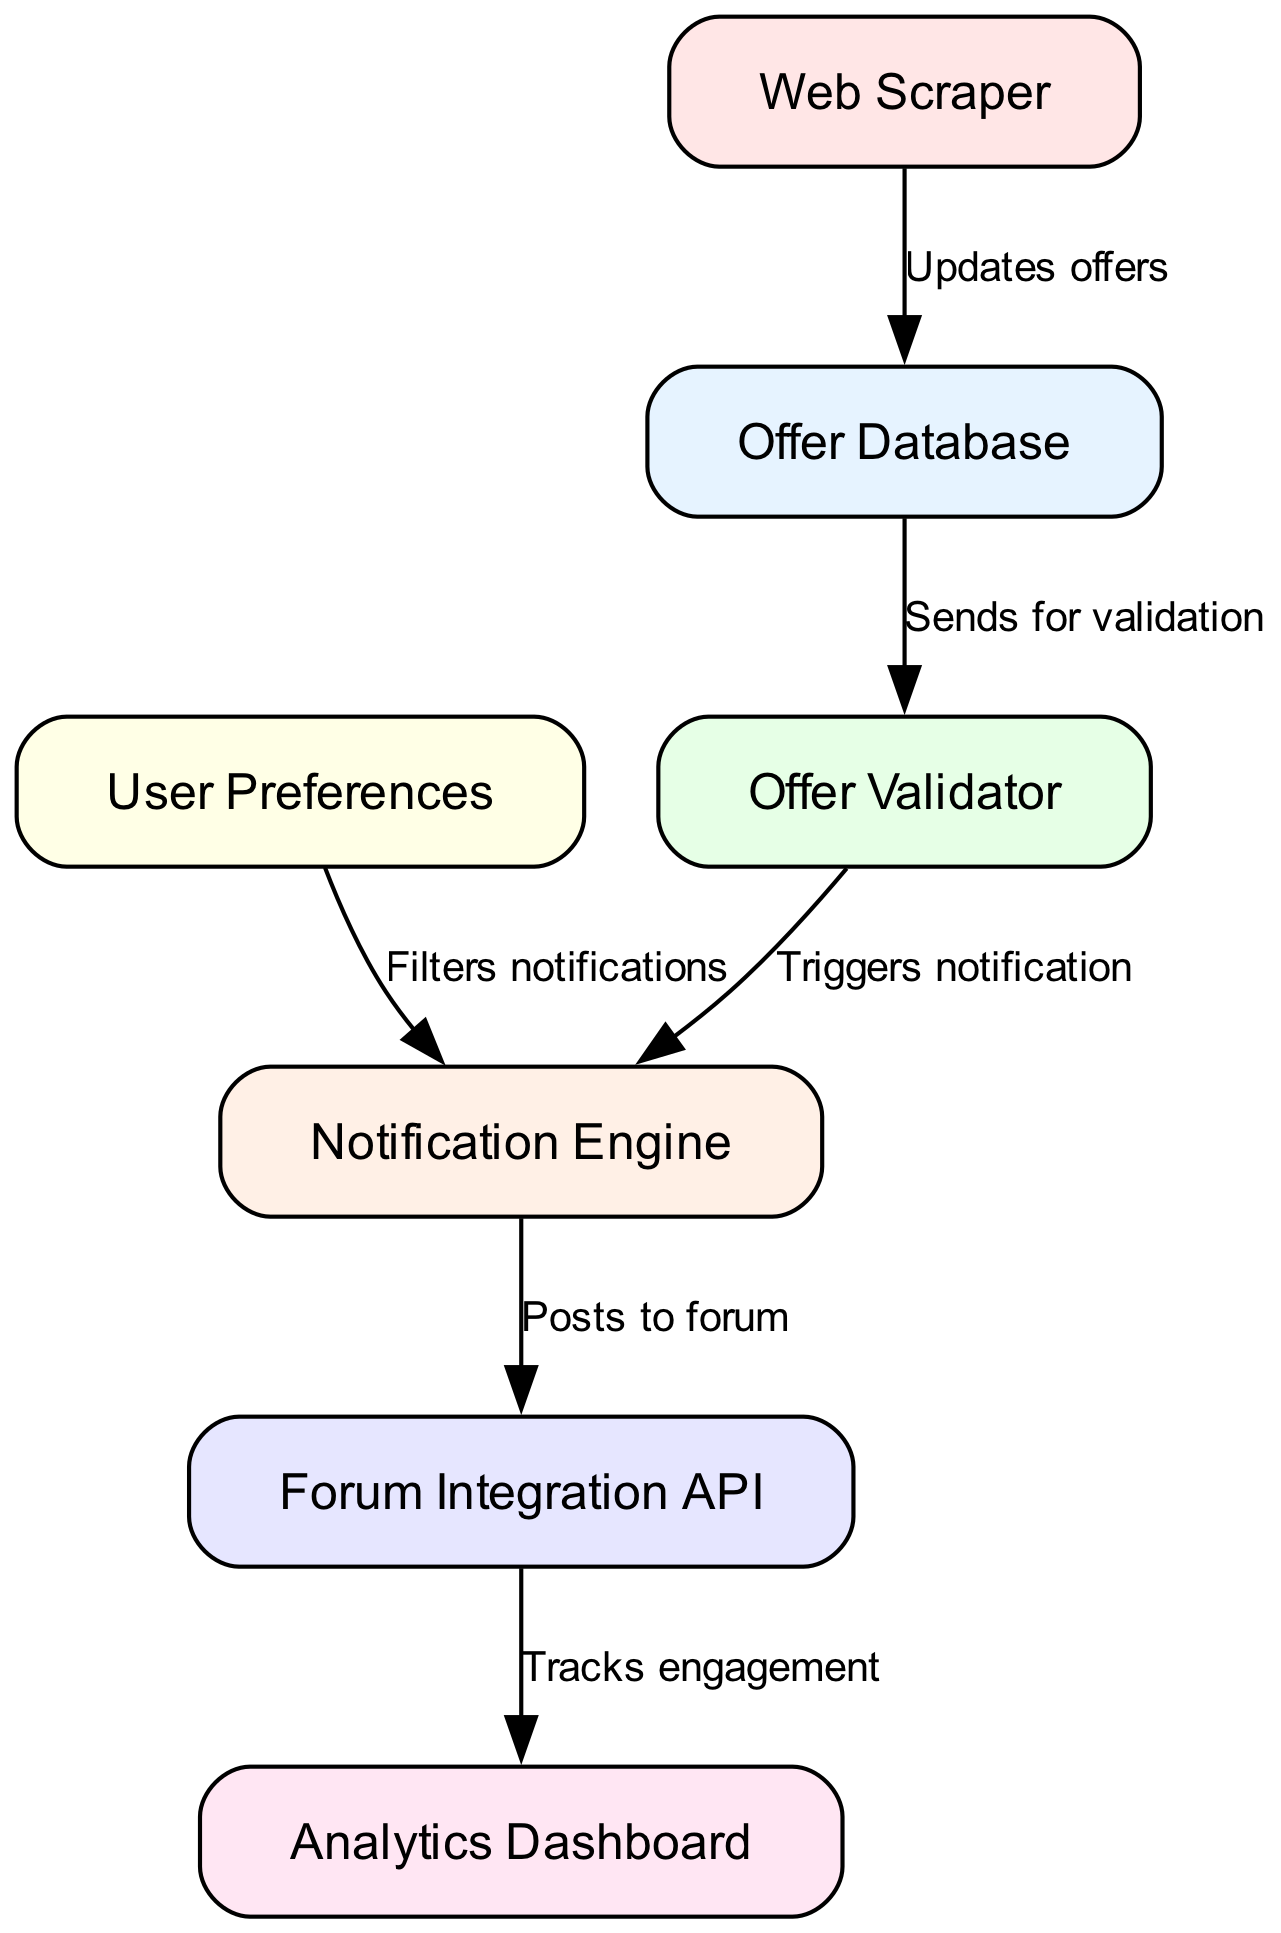What is the total number of nodes in the diagram? The diagram lists nodes for each component of the system, which includes the Offer Database, Web Scraper, Offer Validator, Notification Engine, Forum Integration API, User Preferences, and Analytics Dashboard. Counting these, there are seven nodes.
Answer: 7 What does the Web Scraper update? According to the diagram, the Web Scraper's function is to update the Offer Database. This relationship is indicated by a directed edge from the Web Scraper to the Offer Database with the label "Updates offers".
Answer: Offer Database Which node triggers the notification? The Offer Validator sends a signal to the Notification Engine to trigger notifications, as shown by the directed edge from the Offer Validator to the Notification Engine, labeled "Triggers notification".
Answer: Notification Engine How many directed edges are in the diagram? The diagram features connections between various nodes, represented as directed edges. By counting the edges depicted, there are six edges connecting the seven nodes.
Answer: 6 What filters the notifications before they are sent? The User Preferences node provides the necessary criteria to filter notifications before they reach the Notification Engine, evident from the directed edge connecting User Preferences to Notification Engine, labeled "Filters notifications".
Answer: User Preferences What is the purpose of the Forum Integration API? The Forum Integration API's role is to post notifications to the forum, as indicated by the directed edge from the Notification Engine to the Forum Integration API labeled "Posts to forum".
Answer: Posts to forum What does the Analytics Dashboard track? The Analytics Dashboard tracks user engagement, which is indicated by the directed edge shown in the diagram from the Forum Integration API to the Analytics Dashboard, labeled "Tracks engagement".
Answer: User engagement How does an offer get validated in the system? The process starts with the Web Scraper updating the Offer Database, followed by the Offer Database sending the offers for validation to the Offer Validator. Once validated, it subsequently triggers the Notification Engine, which completes the validation process. This indicates a sequence of steps leading from one node to the next for successful validation.
Answer: Offer Validator 